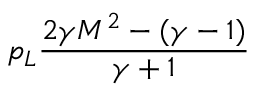Convert formula to latex. <formula><loc_0><loc_0><loc_500><loc_500>p _ { L } \frac { 2 \gamma M ^ { 2 } - ( \gamma - 1 ) } { \gamma + 1 }</formula> 